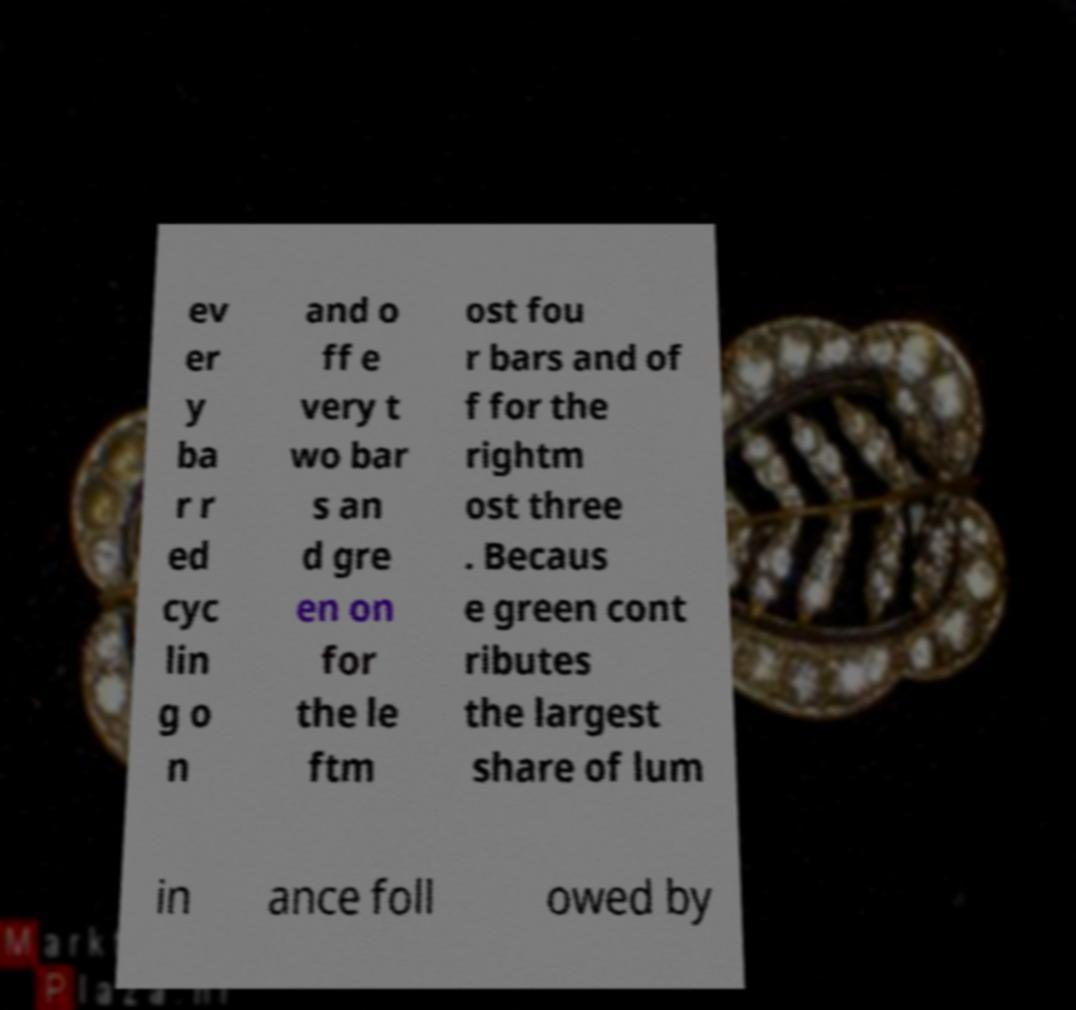Can you accurately transcribe the text from the provided image for me? ev er y ba r r ed cyc lin g o n and o ff e very t wo bar s an d gre en on for the le ftm ost fou r bars and of f for the rightm ost three . Becaus e green cont ributes the largest share of lum in ance foll owed by 